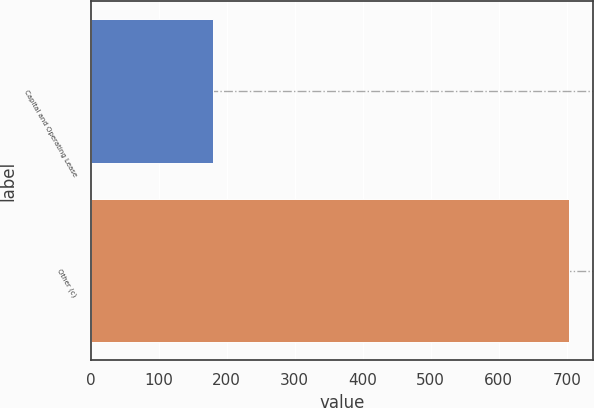<chart> <loc_0><loc_0><loc_500><loc_500><bar_chart><fcel>Capital and Operating Lease<fcel>Other (c)<nl><fcel>180<fcel>704<nl></chart> 